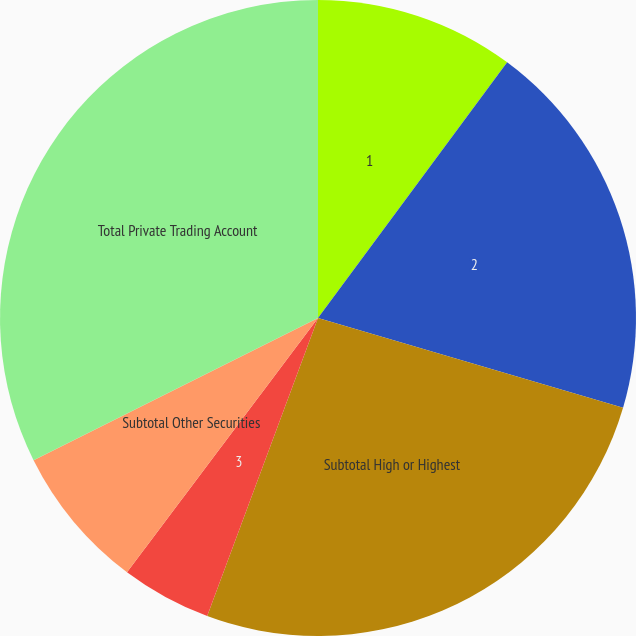Convert chart. <chart><loc_0><loc_0><loc_500><loc_500><pie_chart><fcel>1<fcel>2<fcel>Subtotal High or Highest<fcel>3<fcel>Subtotal Other Securities<fcel>Total Private Trading Account<nl><fcel>10.14%<fcel>19.42%<fcel>26.11%<fcel>4.59%<fcel>7.37%<fcel>32.38%<nl></chart> 